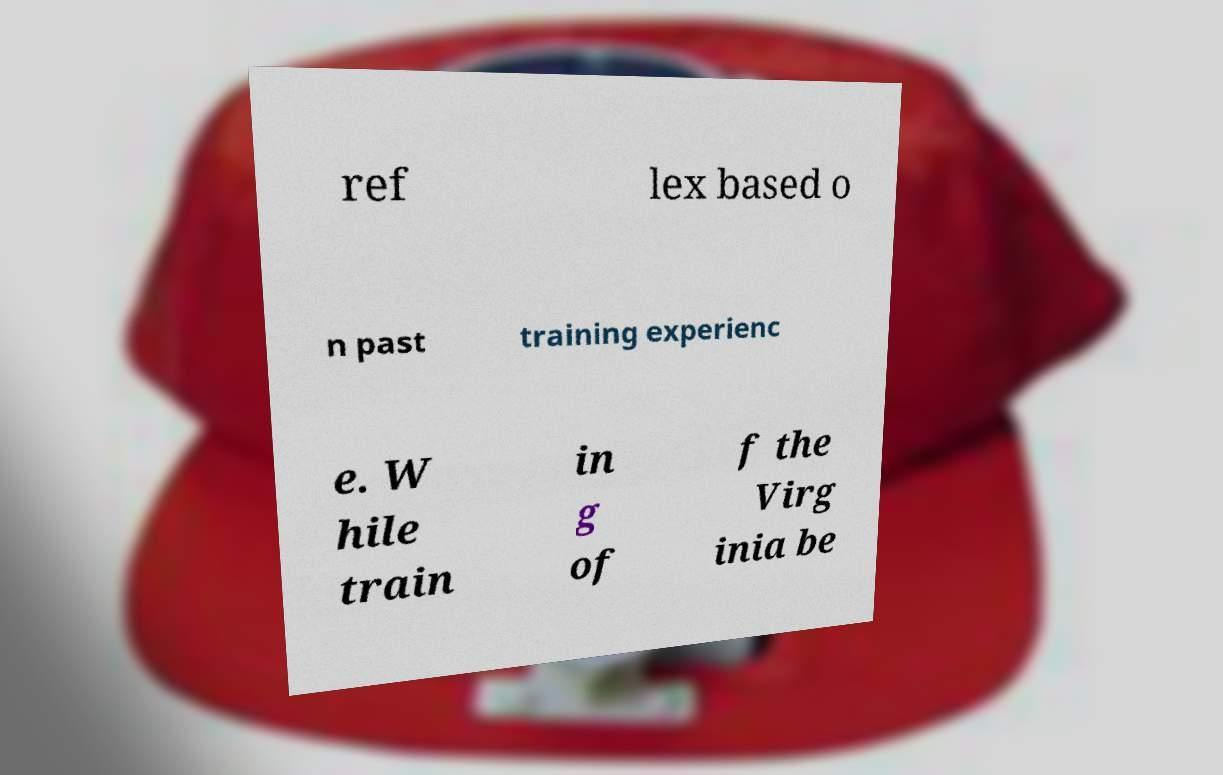Could you extract and type out the text from this image? ref lex based o n past training experienc e. W hile train in g of f the Virg inia be 